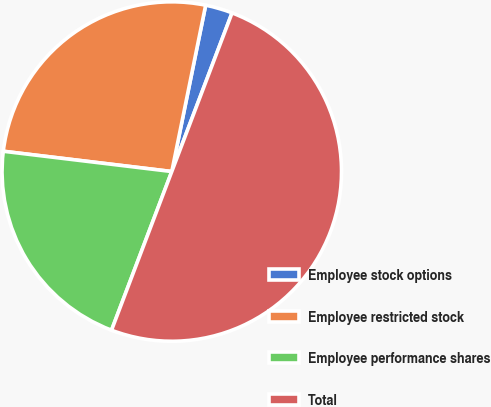<chart> <loc_0><loc_0><loc_500><loc_500><pie_chart><fcel>Employee stock options<fcel>Employee restricted stock<fcel>Employee performance shares<fcel>Total<nl><fcel>2.58%<fcel>26.29%<fcel>21.13%<fcel>50.0%<nl></chart> 